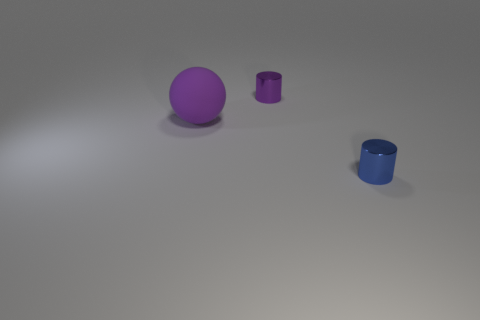Add 1 yellow objects. How many objects exist? 4 Subtract all spheres. How many objects are left? 2 Add 1 small purple metallic things. How many small purple metallic things are left? 2 Add 3 large metal cylinders. How many large metal cylinders exist? 3 Subtract 0 red cylinders. How many objects are left? 3 Subtract all tiny purple objects. Subtract all tiny blue metal cylinders. How many objects are left? 1 